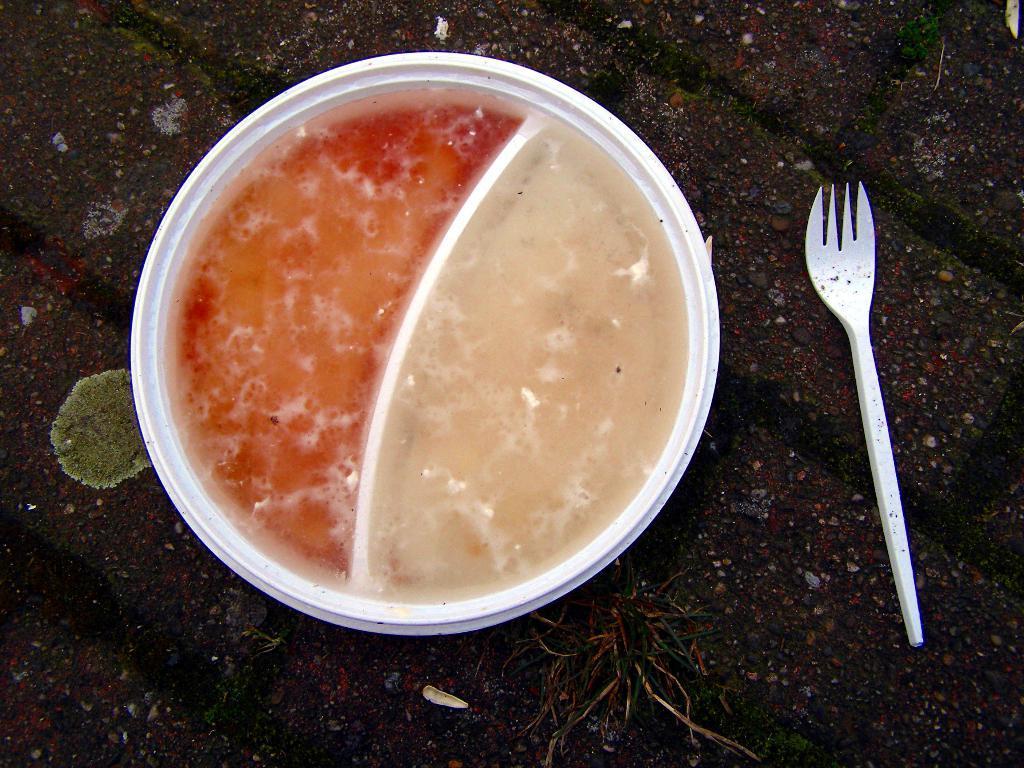In one or two sentences, can you explain what this image depicts? In this picture we can see a box which is white in colour and there is partition in between the box. This is a food and beside the box there is a fork which is white in colour. 